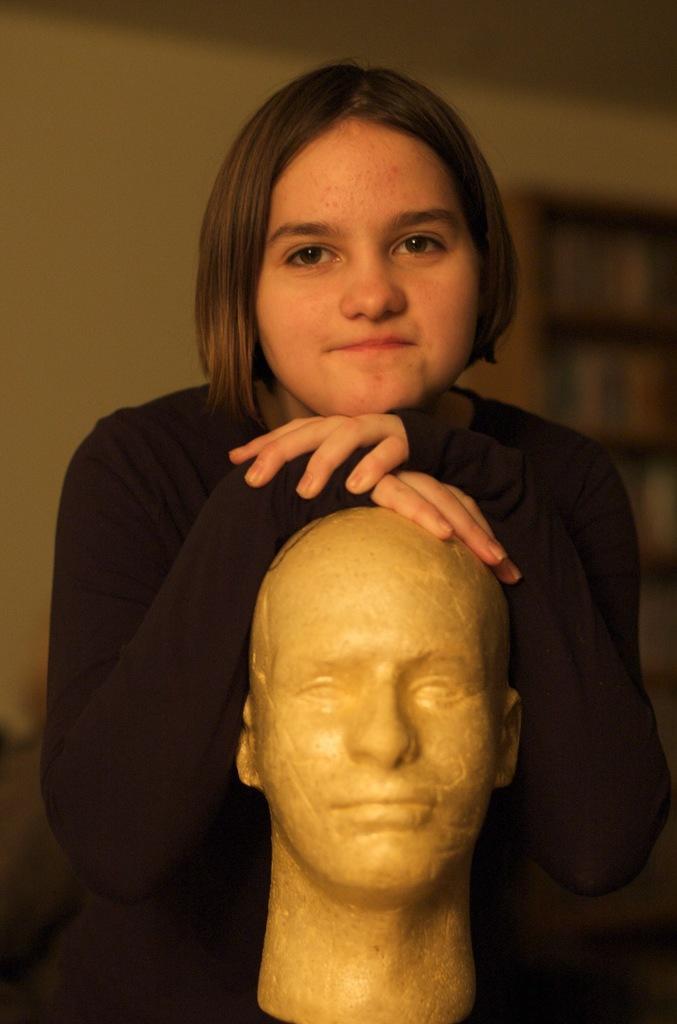Please provide a concise description of this image. In this image, we can see a girl standing and she is putting in her hands on the statue head, in the background we can see a wall. 